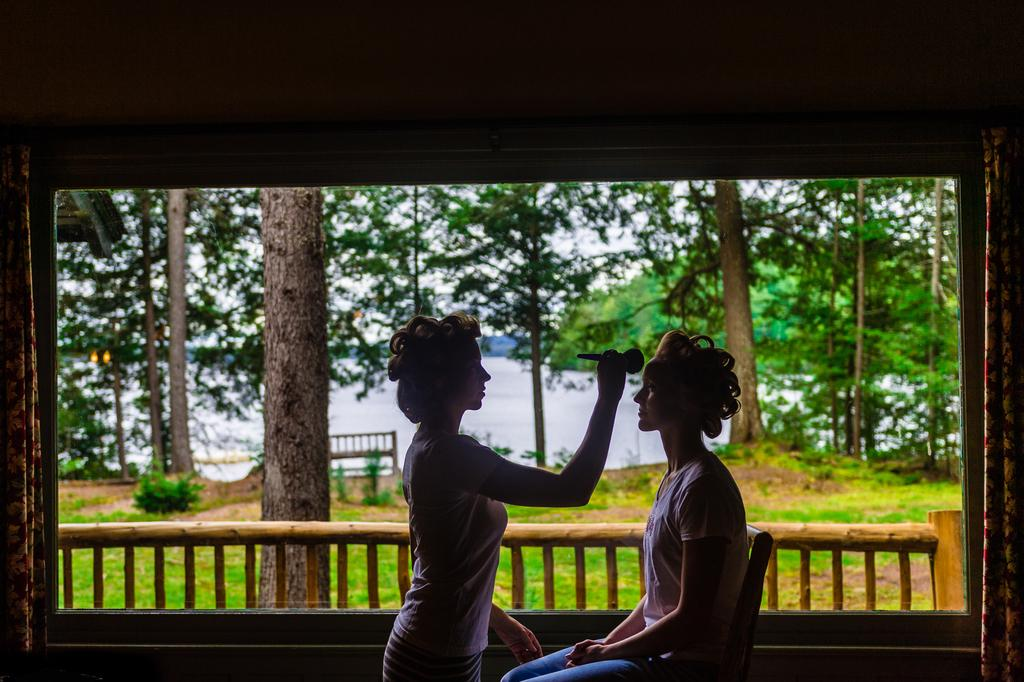How many people are in the image? There are two people in the image. What can be seen in the background of the image? There is a fence, trees, water, a bench, and the sky visible in the background of the image. What type of pain can be seen in the eye of one of the people in the image? There is no indication of pain or any eye-related issues in the image; both people appear to be looking at the scene in front of them. 